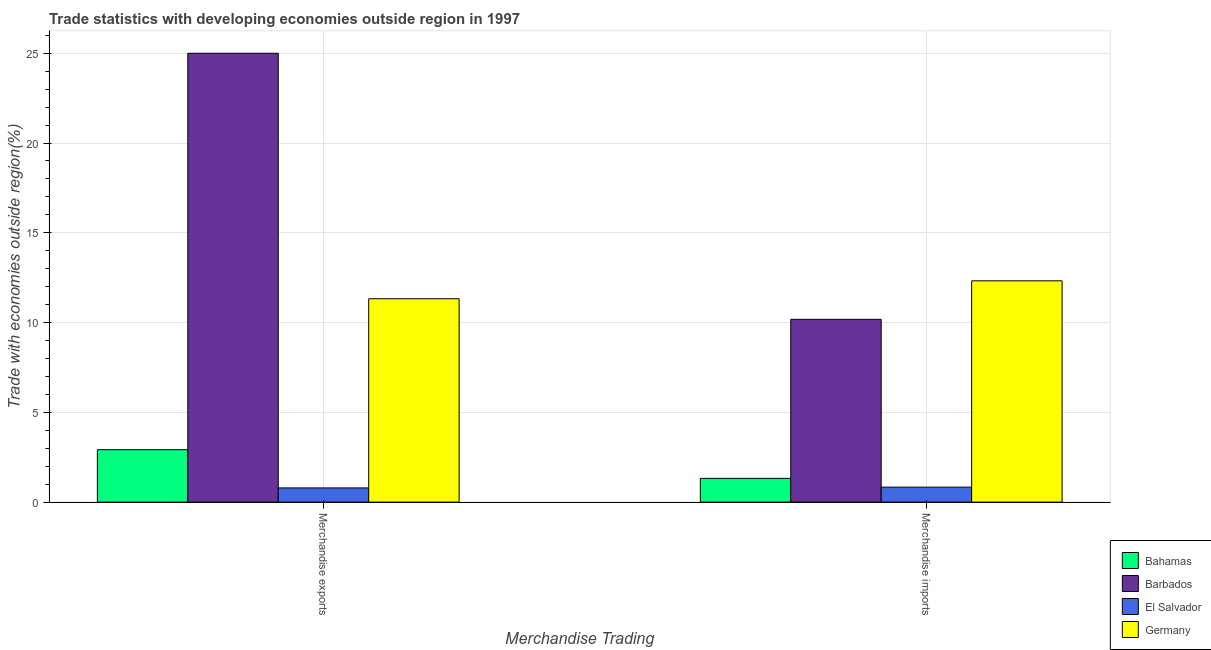How many groups of bars are there?
Ensure brevity in your answer.  2. Are the number of bars per tick equal to the number of legend labels?
Offer a very short reply. Yes. What is the label of the 1st group of bars from the left?
Provide a short and direct response. Merchandise exports. What is the merchandise imports in Bahamas?
Offer a very short reply. 1.32. Across all countries, what is the maximum merchandise imports?
Make the answer very short. 12.32. Across all countries, what is the minimum merchandise imports?
Offer a terse response. 0.83. In which country was the merchandise imports maximum?
Your response must be concise. Germany. In which country was the merchandise imports minimum?
Keep it short and to the point. El Salvador. What is the total merchandise imports in the graph?
Provide a short and direct response. 24.66. What is the difference between the merchandise exports in Barbados and that in El Salvador?
Your response must be concise. 24.21. What is the difference between the merchandise exports in Bahamas and the merchandise imports in El Salvador?
Your answer should be compact. 2.09. What is the average merchandise exports per country?
Your response must be concise. 10.01. What is the difference between the merchandise exports and merchandise imports in Bahamas?
Keep it short and to the point. 1.6. In how many countries, is the merchandise exports greater than 17 %?
Offer a very short reply. 1. What is the ratio of the merchandise imports in Bahamas to that in Barbados?
Your answer should be very brief. 0.13. Is the merchandise imports in Barbados less than that in El Salvador?
Provide a short and direct response. No. In how many countries, is the merchandise exports greater than the average merchandise exports taken over all countries?
Keep it short and to the point. 2. How many bars are there?
Keep it short and to the point. 8. How many countries are there in the graph?
Make the answer very short. 4. How many legend labels are there?
Offer a very short reply. 4. What is the title of the graph?
Your answer should be very brief. Trade statistics with developing economies outside region in 1997. Does "Haiti" appear as one of the legend labels in the graph?
Ensure brevity in your answer.  No. What is the label or title of the X-axis?
Your answer should be compact. Merchandise Trading. What is the label or title of the Y-axis?
Give a very brief answer. Trade with economies outside region(%). What is the Trade with economies outside region(%) in Bahamas in Merchandise exports?
Your answer should be very brief. 2.92. What is the Trade with economies outside region(%) in Barbados in Merchandise exports?
Offer a very short reply. 25. What is the Trade with economies outside region(%) of El Salvador in Merchandise exports?
Give a very brief answer. 0.79. What is the Trade with economies outside region(%) in Germany in Merchandise exports?
Ensure brevity in your answer.  11.33. What is the Trade with economies outside region(%) in Bahamas in Merchandise imports?
Offer a terse response. 1.32. What is the Trade with economies outside region(%) of Barbados in Merchandise imports?
Provide a short and direct response. 10.18. What is the Trade with economies outside region(%) in El Salvador in Merchandise imports?
Keep it short and to the point. 0.83. What is the Trade with economies outside region(%) in Germany in Merchandise imports?
Give a very brief answer. 12.32. Across all Merchandise Trading, what is the maximum Trade with economies outside region(%) in Bahamas?
Keep it short and to the point. 2.92. Across all Merchandise Trading, what is the maximum Trade with economies outside region(%) in Barbados?
Offer a very short reply. 25. Across all Merchandise Trading, what is the maximum Trade with economies outside region(%) of El Salvador?
Your response must be concise. 0.83. Across all Merchandise Trading, what is the maximum Trade with economies outside region(%) of Germany?
Your response must be concise. 12.32. Across all Merchandise Trading, what is the minimum Trade with economies outside region(%) in Bahamas?
Ensure brevity in your answer.  1.32. Across all Merchandise Trading, what is the minimum Trade with economies outside region(%) of Barbados?
Offer a very short reply. 10.18. Across all Merchandise Trading, what is the minimum Trade with economies outside region(%) of El Salvador?
Offer a terse response. 0.79. Across all Merchandise Trading, what is the minimum Trade with economies outside region(%) of Germany?
Provide a short and direct response. 11.33. What is the total Trade with economies outside region(%) in Bahamas in the graph?
Offer a very short reply. 4.24. What is the total Trade with economies outside region(%) in Barbados in the graph?
Give a very brief answer. 35.18. What is the total Trade with economies outside region(%) of El Salvador in the graph?
Give a very brief answer. 1.63. What is the total Trade with economies outside region(%) of Germany in the graph?
Provide a succinct answer. 23.65. What is the difference between the Trade with economies outside region(%) of Bahamas in Merchandise exports and that in Merchandise imports?
Provide a succinct answer. 1.6. What is the difference between the Trade with economies outside region(%) in Barbados in Merchandise exports and that in Merchandise imports?
Provide a succinct answer. 14.82. What is the difference between the Trade with economies outside region(%) in El Salvador in Merchandise exports and that in Merchandise imports?
Provide a succinct answer. -0.04. What is the difference between the Trade with economies outside region(%) in Germany in Merchandise exports and that in Merchandise imports?
Make the answer very short. -1. What is the difference between the Trade with economies outside region(%) in Bahamas in Merchandise exports and the Trade with economies outside region(%) in Barbados in Merchandise imports?
Offer a very short reply. -7.26. What is the difference between the Trade with economies outside region(%) of Bahamas in Merchandise exports and the Trade with economies outside region(%) of El Salvador in Merchandise imports?
Keep it short and to the point. 2.09. What is the difference between the Trade with economies outside region(%) in Bahamas in Merchandise exports and the Trade with economies outside region(%) in Germany in Merchandise imports?
Offer a terse response. -9.4. What is the difference between the Trade with economies outside region(%) of Barbados in Merchandise exports and the Trade with economies outside region(%) of El Salvador in Merchandise imports?
Give a very brief answer. 24.17. What is the difference between the Trade with economies outside region(%) of Barbados in Merchandise exports and the Trade with economies outside region(%) of Germany in Merchandise imports?
Your answer should be compact. 12.67. What is the difference between the Trade with economies outside region(%) of El Salvador in Merchandise exports and the Trade with economies outside region(%) of Germany in Merchandise imports?
Your answer should be very brief. -11.53. What is the average Trade with economies outside region(%) of Bahamas per Merchandise Trading?
Ensure brevity in your answer.  2.12. What is the average Trade with economies outside region(%) in Barbados per Merchandise Trading?
Keep it short and to the point. 17.59. What is the average Trade with economies outside region(%) of El Salvador per Merchandise Trading?
Provide a short and direct response. 0.81. What is the average Trade with economies outside region(%) of Germany per Merchandise Trading?
Your answer should be very brief. 11.83. What is the difference between the Trade with economies outside region(%) in Bahamas and Trade with economies outside region(%) in Barbados in Merchandise exports?
Keep it short and to the point. -22.08. What is the difference between the Trade with economies outside region(%) in Bahamas and Trade with economies outside region(%) in El Salvador in Merchandise exports?
Offer a terse response. 2.13. What is the difference between the Trade with economies outside region(%) in Bahamas and Trade with economies outside region(%) in Germany in Merchandise exports?
Ensure brevity in your answer.  -8.41. What is the difference between the Trade with economies outside region(%) in Barbados and Trade with economies outside region(%) in El Salvador in Merchandise exports?
Provide a short and direct response. 24.21. What is the difference between the Trade with economies outside region(%) in Barbados and Trade with economies outside region(%) in Germany in Merchandise exports?
Your answer should be compact. 13.67. What is the difference between the Trade with economies outside region(%) in El Salvador and Trade with economies outside region(%) in Germany in Merchandise exports?
Provide a short and direct response. -10.54. What is the difference between the Trade with economies outside region(%) of Bahamas and Trade with economies outside region(%) of Barbados in Merchandise imports?
Give a very brief answer. -8.86. What is the difference between the Trade with economies outside region(%) of Bahamas and Trade with economies outside region(%) of El Salvador in Merchandise imports?
Provide a succinct answer. 0.49. What is the difference between the Trade with economies outside region(%) in Bahamas and Trade with economies outside region(%) in Germany in Merchandise imports?
Offer a terse response. -11. What is the difference between the Trade with economies outside region(%) in Barbados and Trade with economies outside region(%) in El Salvador in Merchandise imports?
Provide a short and direct response. 9.35. What is the difference between the Trade with economies outside region(%) in Barbados and Trade with economies outside region(%) in Germany in Merchandise imports?
Offer a very short reply. -2.14. What is the difference between the Trade with economies outside region(%) of El Salvador and Trade with economies outside region(%) of Germany in Merchandise imports?
Ensure brevity in your answer.  -11.49. What is the ratio of the Trade with economies outside region(%) in Bahamas in Merchandise exports to that in Merchandise imports?
Ensure brevity in your answer.  2.21. What is the ratio of the Trade with economies outside region(%) in Barbados in Merchandise exports to that in Merchandise imports?
Offer a very short reply. 2.46. What is the ratio of the Trade with economies outside region(%) in El Salvador in Merchandise exports to that in Merchandise imports?
Provide a succinct answer. 0.95. What is the ratio of the Trade with economies outside region(%) of Germany in Merchandise exports to that in Merchandise imports?
Provide a succinct answer. 0.92. What is the difference between the highest and the second highest Trade with economies outside region(%) in Bahamas?
Ensure brevity in your answer.  1.6. What is the difference between the highest and the second highest Trade with economies outside region(%) in Barbados?
Your answer should be very brief. 14.82. What is the difference between the highest and the second highest Trade with economies outside region(%) in El Salvador?
Offer a very short reply. 0.04. What is the difference between the highest and the second highest Trade with economies outside region(%) in Germany?
Your answer should be very brief. 1. What is the difference between the highest and the lowest Trade with economies outside region(%) in Bahamas?
Keep it short and to the point. 1.6. What is the difference between the highest and the lowest Trade with economies outside region(%) of Barbados?
Keep it short and to the point. 14.82. What is the difference between the highest and the lowest Trade with economies outside region(%) of El Salvador?
Provide a succinct answer. 0.04. 